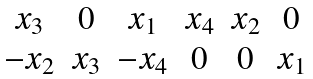<formula> <loc_0><loc_0><loc_500><loc_500>\begin{matrix} x _ { 3 } & 0 & x _ { 1 } & x _ { 4 } & x _ { 2 } & 0 \\ - x _ { 2 } & x _ { 3 } & - x _ { 4 } & 0 & 0 & x _ { 1 } \end{matrix}</formula> 